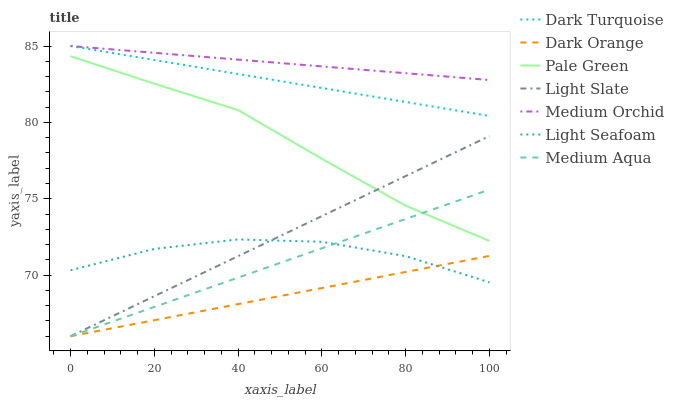Does Dark Orange have the minimum area under the curve?
Answer yes or no. Yes. Does Medium Orchid have the maximum area under the curve?
Answer yes or no. Yes. Does Light Slate have the minimum area under the curve?
Answer yes or no. No. Does Light Slate have the maximum area under the curve?
Answer yes or no. No. Is Dark Orange the smoothest?
Answer yes or no. Yes. Is Light Seafoam the roughest?
Answer yes or no. Yes. Is Light Slate the smoothest?
Answer yes or no. No. Is Light Slate the roughest?
Answer yes or no. No. Does Dark Orange have the lowest value?
Answer yes or no. Yes. Does Dark Turquoise have the lowest value?
Answer yes or no. No. Does Medium Orchid have the highest value?
Answer yes or no. Yes. Does Light Slate have the highest value?
Answer yes or no. No. Is Light Slate less than Dark Turquoise?
Answer yes or no. Yes. Is Dark Turquoise greater than Light Seafoam?
Answer yes or no. Yes. Does Light Seafoam intersect Medium Aqua?
Answer yes or no. Yes. Is Light Seafoam less than Medium Aqua?
Answer yes or no. No. Is Light Seafoam greater than Medium Aqua?
Answer yes or no. No. Does Light Slate intersect Dark Turquoise?
Answer yes or no. No. 